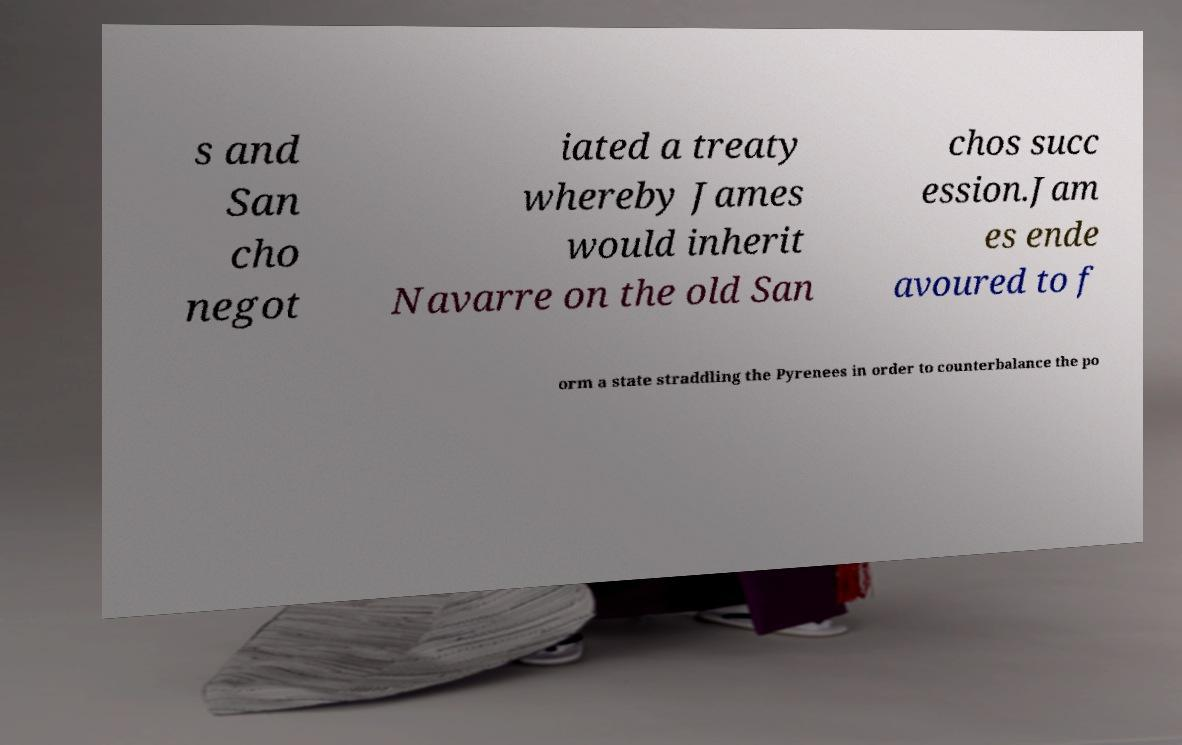There's text embedded in this image that I need extracted. Can you transcribe it verbatim? s and San cho negot iated a treaty whereby James would inherit Navarre on the old San chos succ ession.Jam es ende avoured to f orm a state straddling the Pyrenees in order to counterbalance the po 